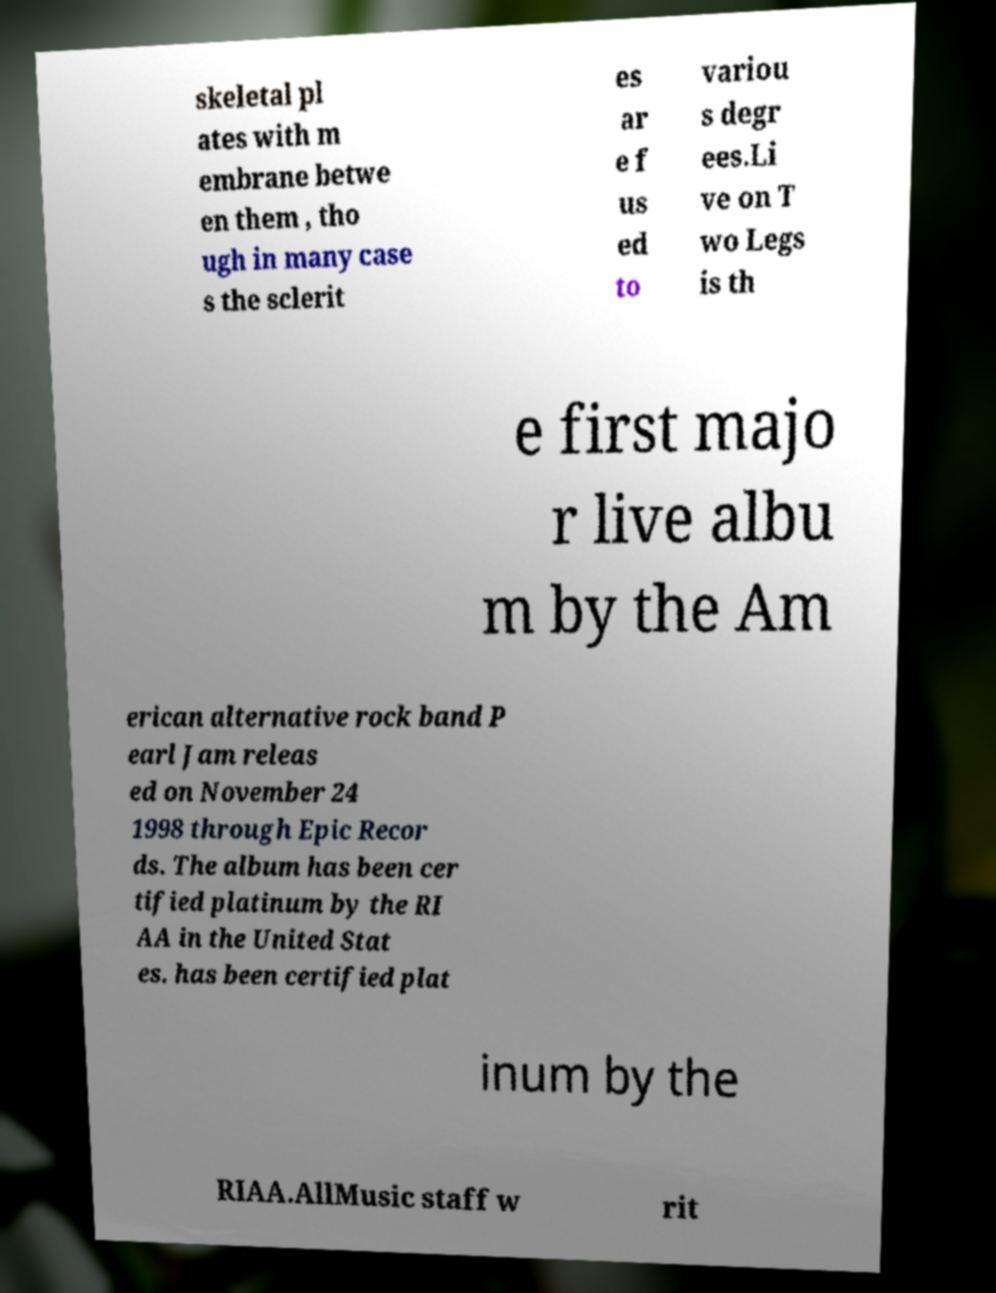For documentation purposes, I need the text within this image transcribed. Could you provide that? skeletal pl ates with m embrane betwe en them , tho ugh in many case s the sclerit es ar e f us ed to variou s degr ees.Li ve on T wo Legs is th e first majo r live albu m by the Am erican alternative rock band P earl Jam releas ed on November 24 1998 through Epic Recor ds. The album has been cer tified platinum by the RI AA in the United Stat es. has been certified plat inum by the RIAA.AllMusic staff w rit 